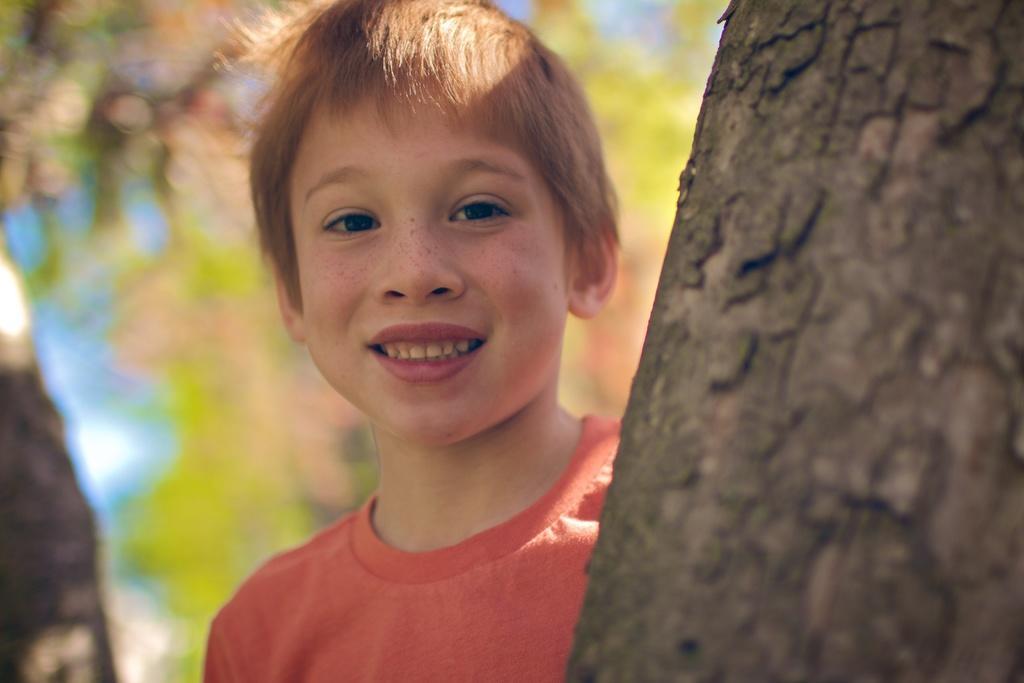Can you describe this image briefly? This image is taken outdoors. In this image the background is a little blurred. On the left side of the image there is a tree. On the right side of the image there is a bark of a tree. In the middle of the image there is a kid and he is with a smiling face. 